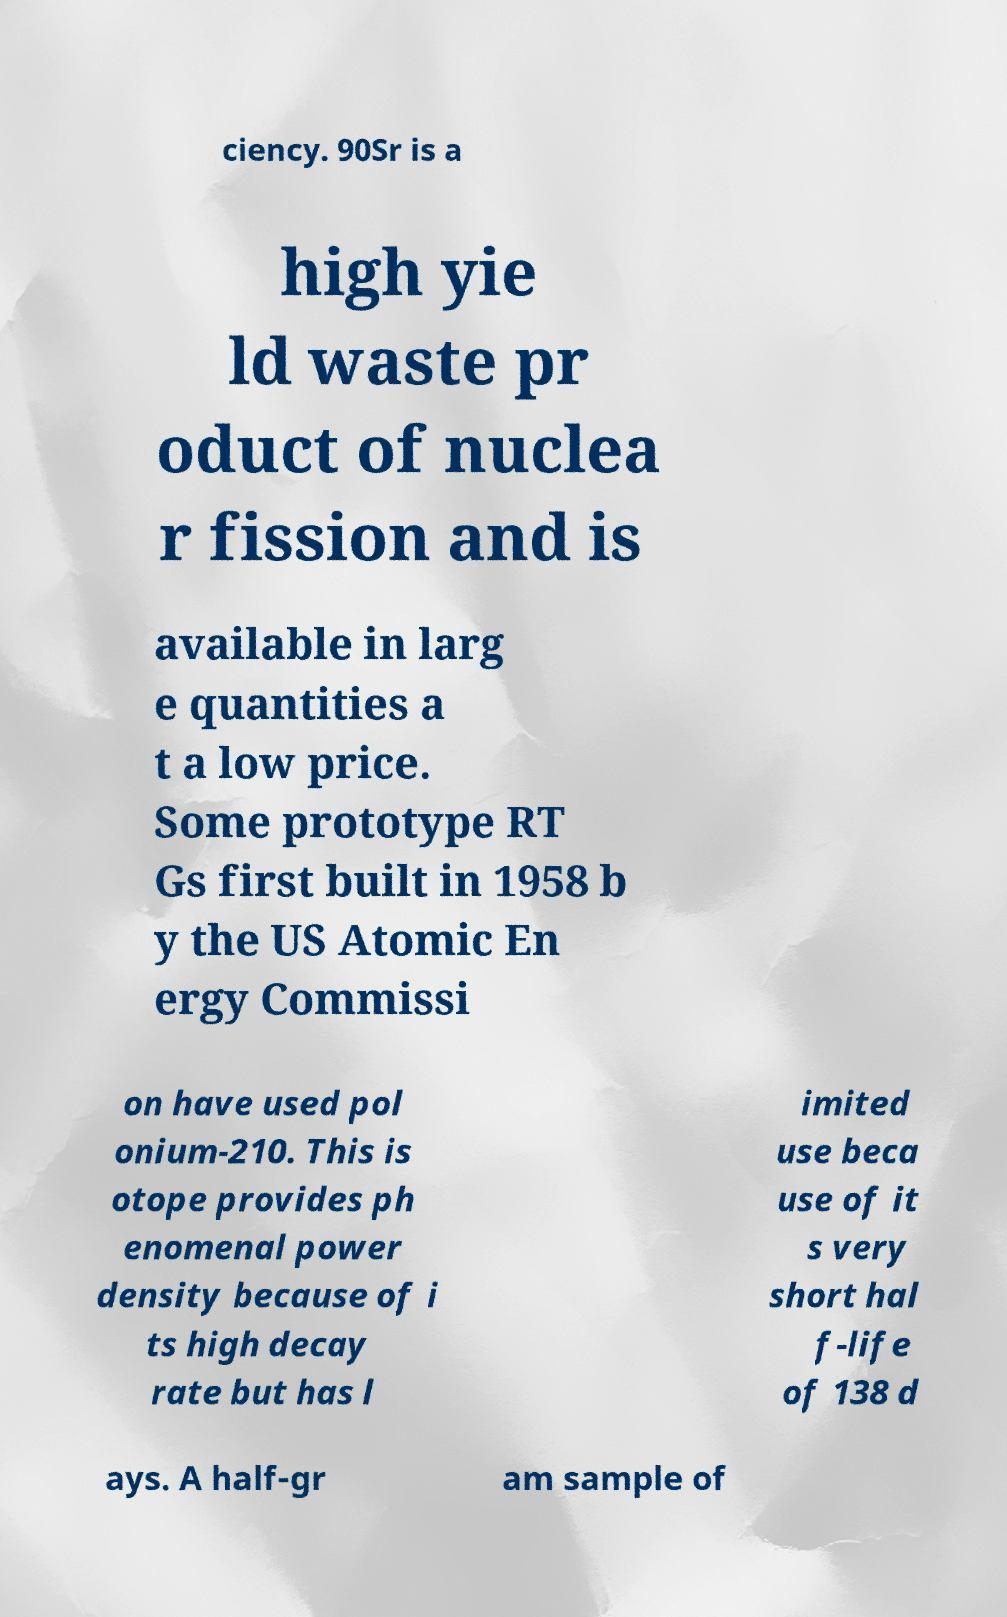Could you assist in decoding the text presented in this image and type it out clearly? ciency. 90Sr is a high yie ld waste pr oduct of nuclea r fission and is available in larg e quantities a t a low price. Some prototype RT Gs first built in 1958 b y the US Atomic En ergy Commissi on have used pol onium-210. This is otope provides ph enomenal power density because of i ts high decay rate but has l imited use beca use of it s very short hal f-life of 138 d ays. A half-gr am sample of 